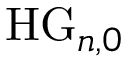Convert formula to latex. <formula><loc_0><loc_0><loc_500><loc_500>H G _ { n , 0 }</formula> 